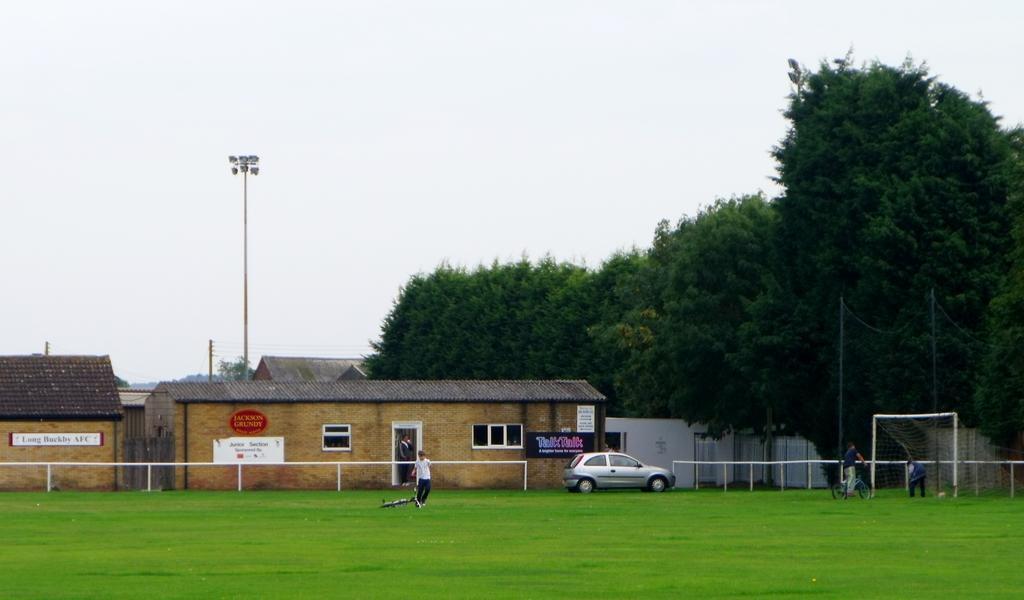Describe this image in one or two sentences. In this image, I can see three persons standing and a person riding bicycle on the grass. There are houses, boarded, a car, trees and lights to a pole. On the right side of the image, I can see a football goal post and fence. In the background, there is the sky. 